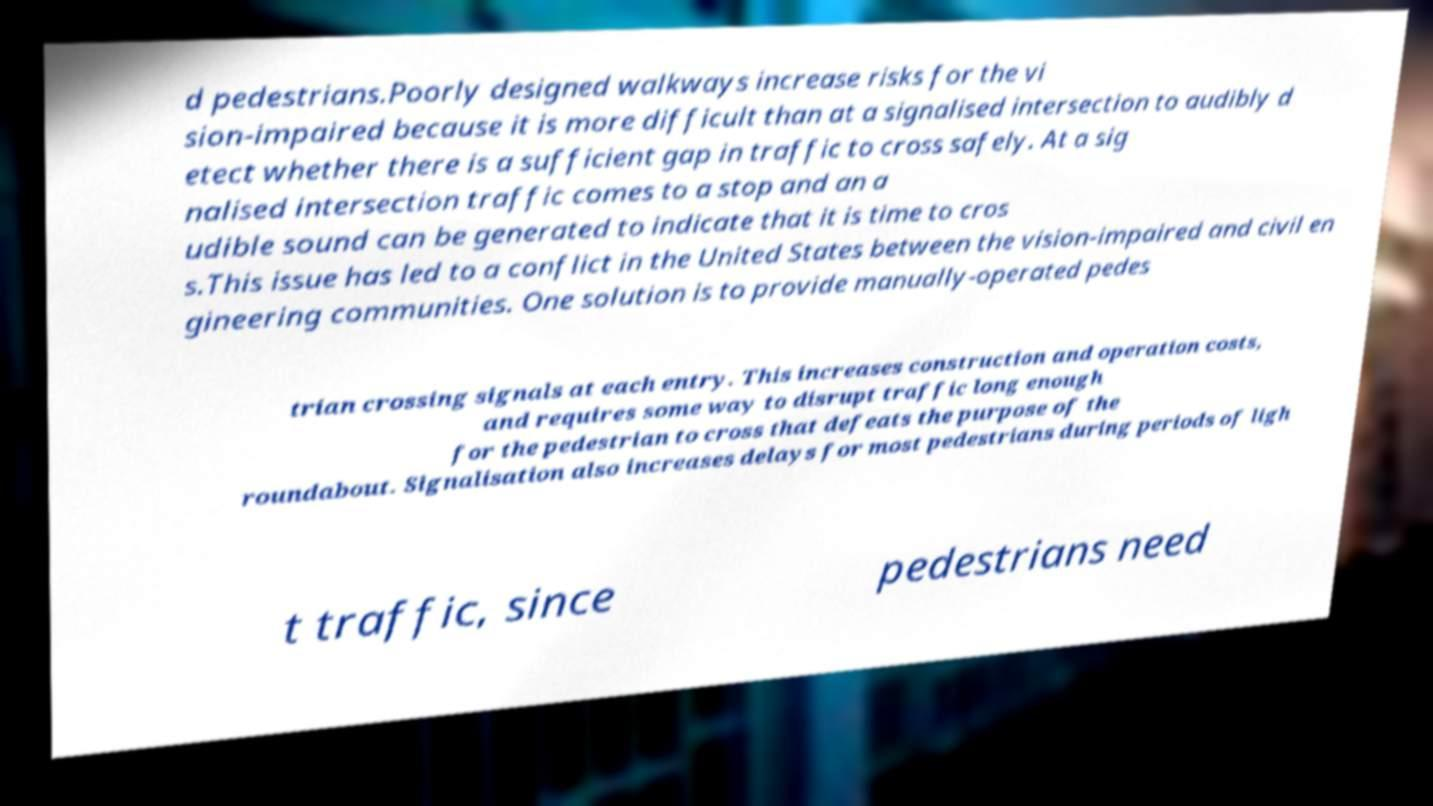Could you assist in decoding the text presented in this image and type it out clearly? d pedestrians.Poorly designed walkways increase risks for the vi sion-impaired because it is more difficult than at a signalised intersection to audibly d etect whether there is a sufficient gap in traffic to cross safely. At a sig nalised intersection traffic comes to a stop and an a udible sound can be generated to indicate that it is time to cros s.This issue has led to a conflict in the United States between the vision-impaired and civil en gineering communities. One solution is to provide manually-operated pedes trian crossing signals at each entry. This increases construction and operation costs, and requires some way to disrupt traffic long enough for the pedestrian to cross that defeats the purpose of the roundabout. Signalisation also increases delays for most pedestrians during periods of ligh t traffic, since pedestrians need 